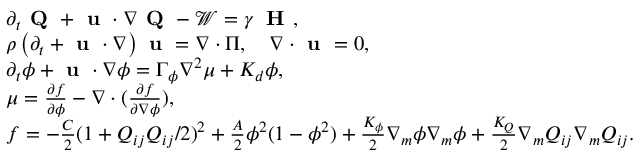<formula> <loc_0><loc_0><loc_500><loc_500>\begin{array} { r l } & { \partial _ { t } Q + u \cdot \nabla Q - \mathcal { W } = \gamma \, H , } \\ & { \rho \left ( \partial _ { t } + u \cdot \nabla \right ) u = \nabla \cdot \Pi , \quad \nabla \cdot u = 0 , } \\ & { \partial _ { t } \phi + u \cdot \nabla \phi = \Gamma _ { \phi } \nabla ^ { 2 } \mu + K _ { d } \phi , } \\ & { \mu = \frac { \partial f } { \partial \phi } - \nabla \cdot ( \frac { \partial f } { \partial \nabla \phi } ) , } \\ & { f = - \frac { C } { 2 } ( 1 + Q _ { i j } Q _ { i j } / 2 ) ^ { 2 } + \frac { A } { 2 } \phi ^ { 2 } ( 1 - \phi ^ { 2 } ) + \frac { K _ { \phi } } { 2 } \nabla _ { m } \phi \nabla _ { m } \phi + \frac { K _ { Q } } { 2 } \nabla _ { m } Q _ { i j } \nabla _ { m } Q _ { i j } . } \end{array}</formula> 